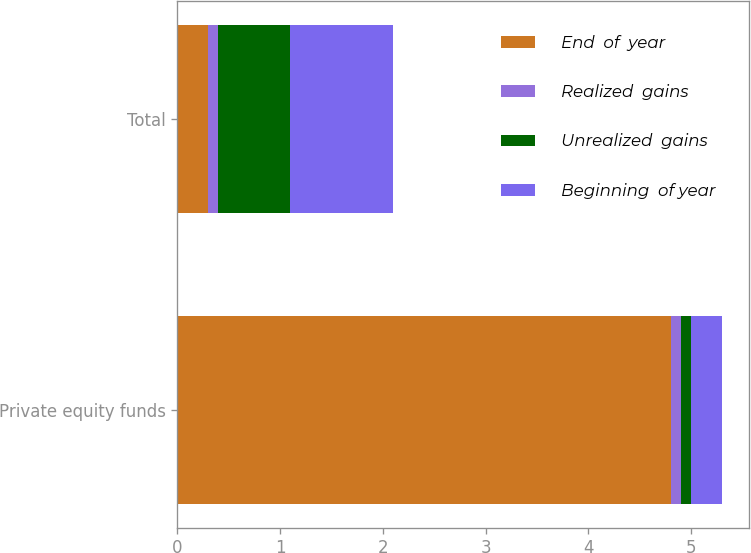Convert chart. <chart><loc_0><loc_0><loc_500><loc_500><stacked_bar_chart><ecel><fcel>Private equity funds<fcel>Total<nl><fcel>End  of  year<fcel>4.8<fcel>0.3<nl><fcel>Realized  gains<fcel>0.1<fcel>0.1<nl><fcel>Unrealized  gains<fcel>0.1<fcel>0.7<nl><fcel>Beginning  of year<fcel>0.3<fcel>1<nl></chart> 